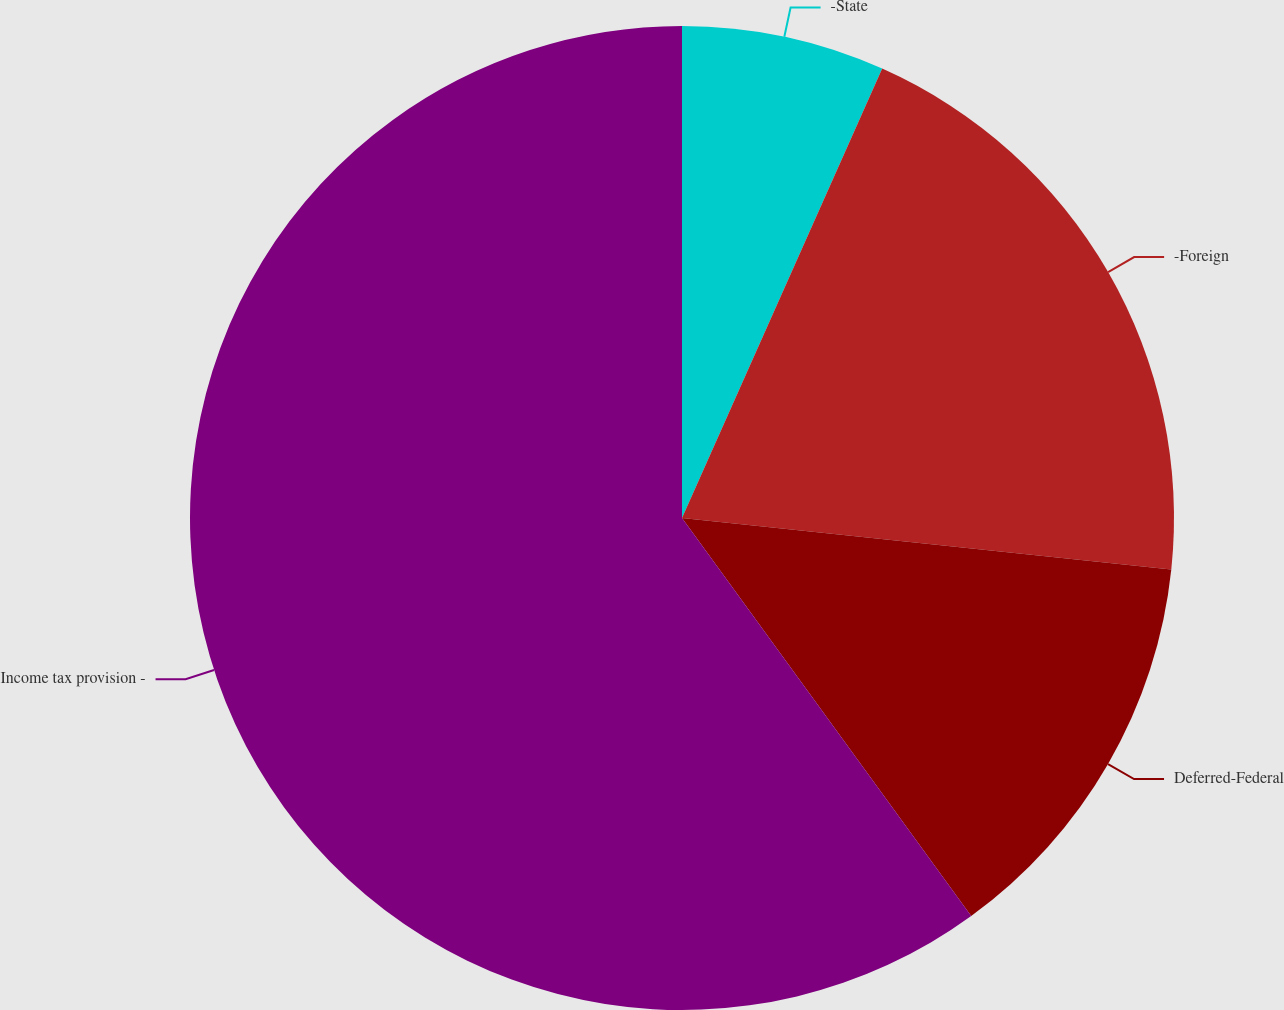Convert chart. <chart><loc_0><loc_0><loc_500><loc_500><pie_chart><fcel>-State<fcel>-Foreign<fcel>Deferred-Federal<fcel>Income tax provision -<nl><fcel>6.67%<fcel>20.0%<fcel>13.33%<fcel>60.0%<nl></chart> 